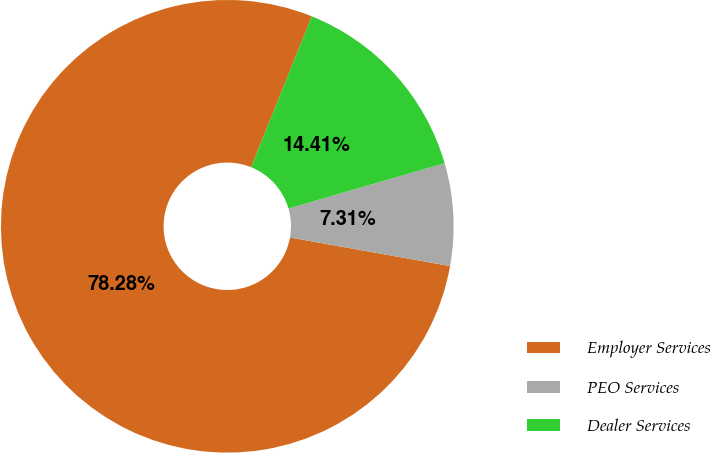Convert chart to OTSL. <chart><loc_0><loc_0><loc_500><loc_500><pie_chart><fcel>Employer Services<fcel>PEO Services<fcel>Dealer Services<nl><fcel>78.29%<fcel>7.31%<fcel>14.41%<nl></chart> 